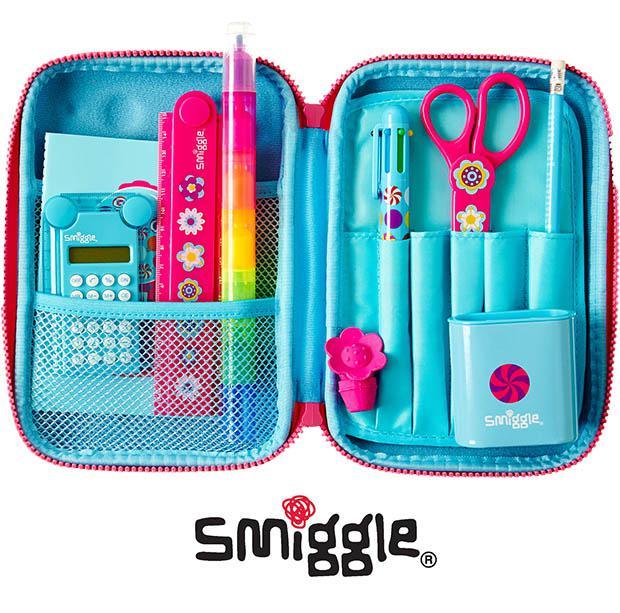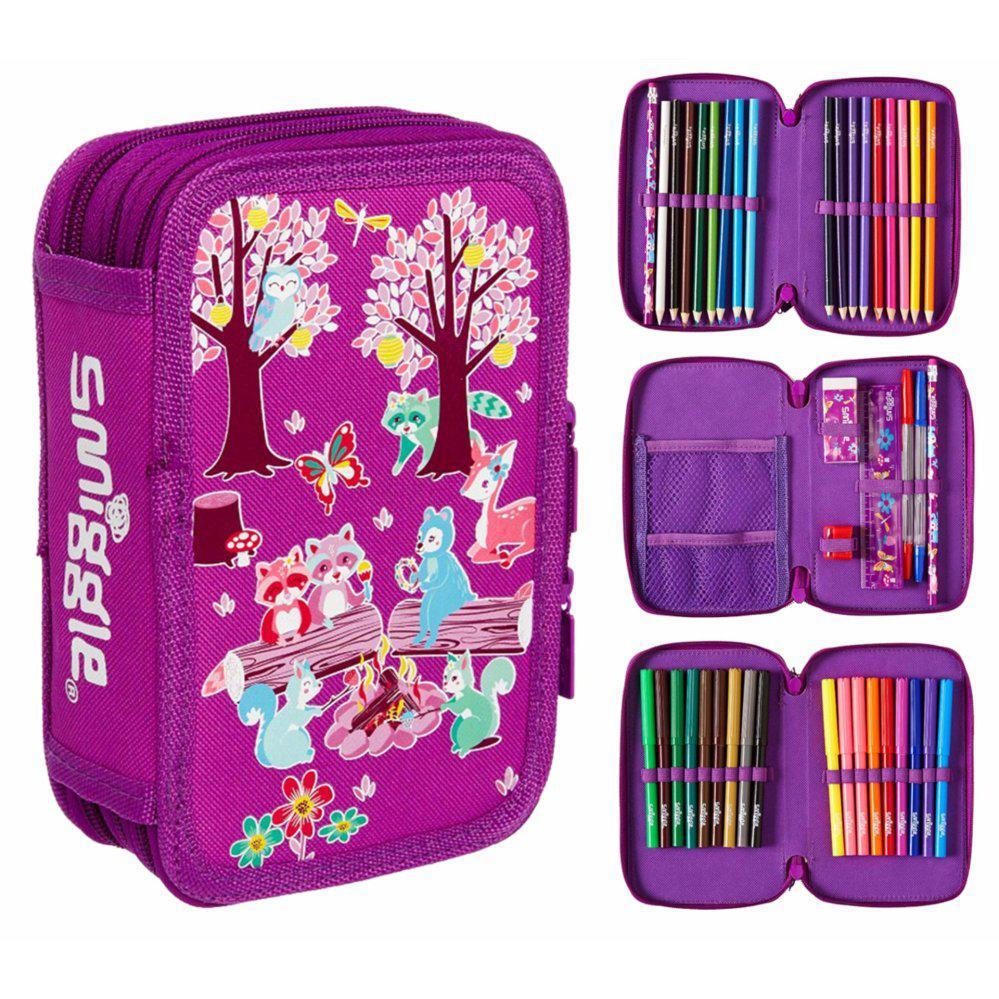The first image is the image on the left, the second image is the image on the right. For the images displayed, is the sentence "A pair of scissors is in the pencil pouch next to a pencil." factually correct? Answer yes or no. Yes. The first image is the image on the left, the second image is the image on the right. Assess this claim about the two images: "One of the containers contains a pair of scissors.". Correct or not? Answer yes or no. Yes. 